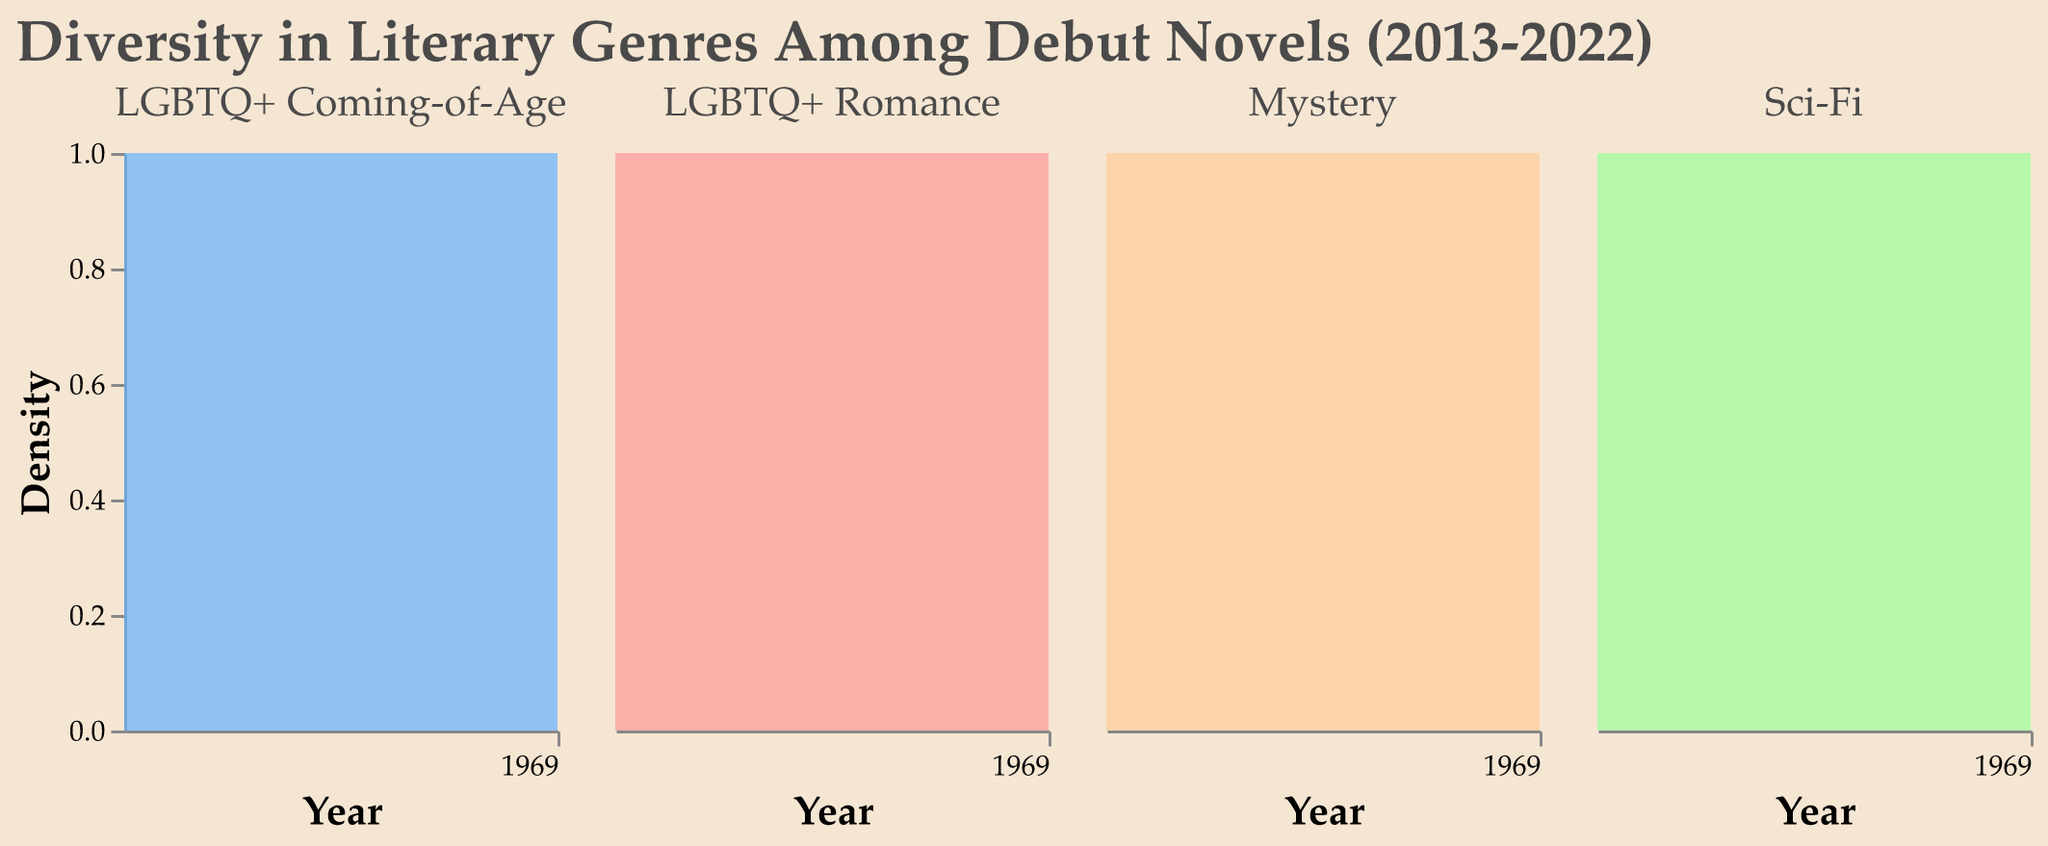What is the title of the figure? The title can be seen at the top of the figure and reads "Diversity in Literary Genres Among Debut Novels (2013-2022)".
Answer: Diversity in Literary Genres Among Debut Novels (2013-2022) Which genre saw the highest density in 2022? The density plot for 2022 shows the peak for the Mystery genre at its highest point.
Answer: Mystery How has the density of LGBTQ+ Romance changed from 2013 to 2022? The density of LGBTQ+ Romance has shown a steady increase from 2013 to 2022 based on the density plot's upward trend.
Answer: Increased In which year did LGBTQ+ Coming-of-Age first surpass a count of 10? By observing the plot for LGBTQ+ Coming-of-Age, the density surpasses a count of 10 starting in the year 2017.
Answer: 2017 Compare the density trends of Sci-Fi and Mystery genres from 2013 to 2022. Both genres have shown an increase in density, but Mystery has a steeper rise and higher density peaks in later years compared to Sci-Fi.
Answer: Mystery increased more Which year had the lowest density for LGBTQ+ Coming-of-Age? The density plot shows the lowest point for LGBTQ+ Coming-of-Age in the year 2014.
Answer: 2014 Describe the trend of the Mystery genre from 2013 to 2022. The density plot for the Mystery genre shows a consistent upward trend from 2013 to 2022, indicating an increase in the number of mystery debut novels.
Answer: Consistent upward trend How does the density of LGBTQ+ Coming-of-Age in 2021 compare to 2015? The density of LGBTQ+ Coming-of-Age is higher in 2021 compared to 2015, based on the plots' peaks.
Answer: Higher in 2021 What genre shows the most variation in density over the decade? Comparing all the plots, LGBTQ+ Coming-of-Age shows the most variation with several ups and downs over the years.
Answer: LGBTQ+ Coming-of-Age Which genres had equal density in 2015? Observing the densities, Mystery and LGBTQ+ Romance have an equal density count in 2015.
Answer: Mystery and LGBTQ+ Romance 